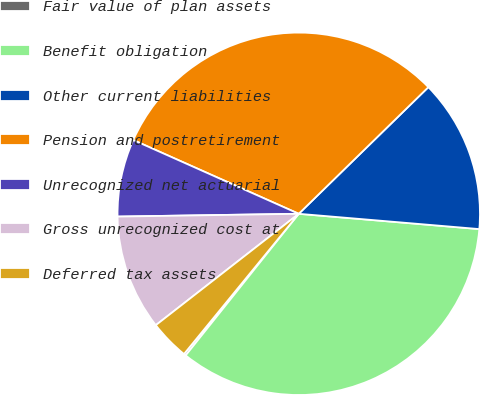Convert chart. <chart><loc_0><loc_0><loc_500><loc_500><pie_chart><fcel>Fair value of plan assets<fcel>Benefit obligation<fcel>Other current liabilities<fcel>Pension and postretirement<fcel>Unrecognized net actuarial<fcel>Gross unrecognized cost at<fcel>Deferred tax assets<nl><fcel>0.19%<fcel>34.38%<fcel>13.66%<fcel>31.01%<fcel>6.92%<fcel>10.29%<fcel>3.55%<nl></chart> 